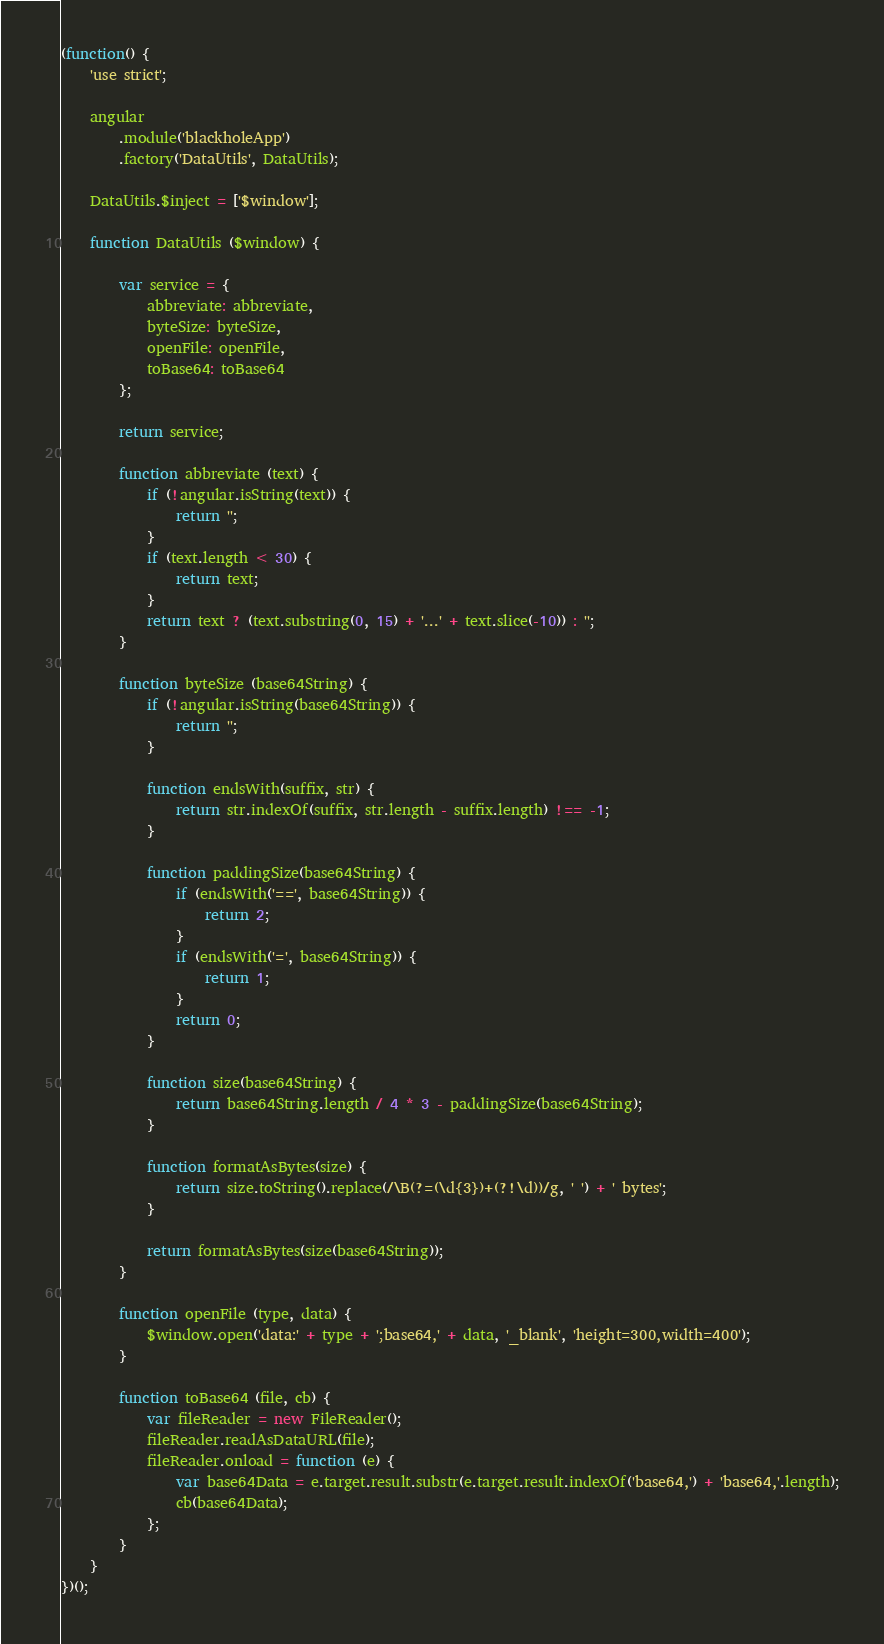Convert code to text. <code><loc_0><loc_0><loc_500><loc_500><_JavaScript_>(function() {
    'use strict';

    angular
        .module('blackholeApp')
        .factory('DataUtils', DataUtils);

    DataUtils.$inject = ['$window'];

    function DataUtils ($window) {

        var service = {
            abbreviate: abbreviate,
            byteSize: byteSize,
            openFile: openFile,
            toBase64: toBase64
        };

        return service;

        function abbreviate (text) {
            if (!angular.isString(text)) {
                return '';
            }
            if (text.length < 30) {
                return text;
            }
            return text ? (text.substring(0, 15) + '...' + text.slice(-10)) : '';
        }

        function byteSize (base64String) {
            if (!angular.isString(base64String)) {
                return '';
            }

            function endsWith(suffix, str) {
                return str.indexOf(suffix, str.length - suffix.length) !== -1;
            }

            function paddingSize(base64String) {
                if (endsWith('==', base64String)) {
                    return 2;
                }
                if (endsWith('=', base64String)) {
                    return 1;
                }
                return 0;
            }

            function size(base64String) {
                return base64String.length / 4 * 3 - paddingSize(base64String);
            }

            function formatAsBytes(size) {
                return size.toString().replace(/\B(?=(\d{3})+(?!\d))/g, ' ') + ' bytes';
            }

            return formatAsBytes(size(base64String));
        }

        function openFile (type, data) {
            $window.open('data:' + type + ';base64,' + data, '_blank', 'height=300,width=400');
        }

        function toBase64 (file, cb) {
            var fileReader = new FileReader();
            fileReader.readAsDataURL(file);
            fileReader.onload = function (e) {
                var base64Data = e.target.result.substr(e.target.result.indexOf('base64,') + 'base64,'.length);
                cb(base64Data);
            };
        }
    }
})();
</code> 